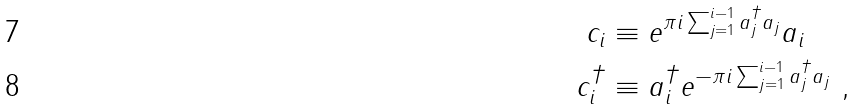Convert formula to latex. <formula><loc_0><loc_0><loc_500><loc_500>c _ { i } & \equiv e ^ { \pi i \sum ^ { i - 1 } _ { j = 1 } a ^ { \dagger } _ { j } a _ { j } } a _ { i } \\ c ^ { \dagger } _ { i } & \equiv a ^ { \dagger } _ { i } e ^ { - \pi i \sum ^ { i - 1 } _ { j = 1 } a ^ { \dagger } _ { j } a _ { j } } \ ,</formula> 